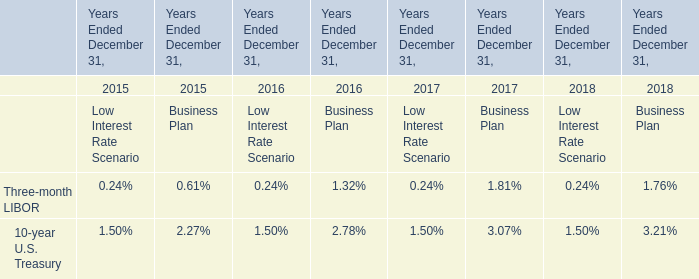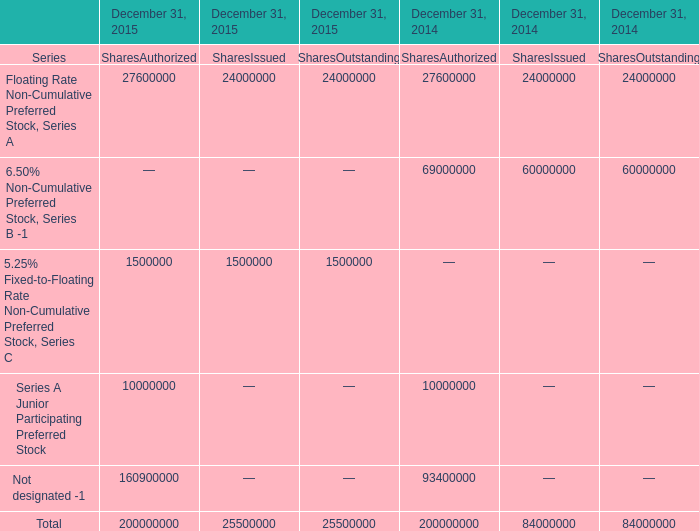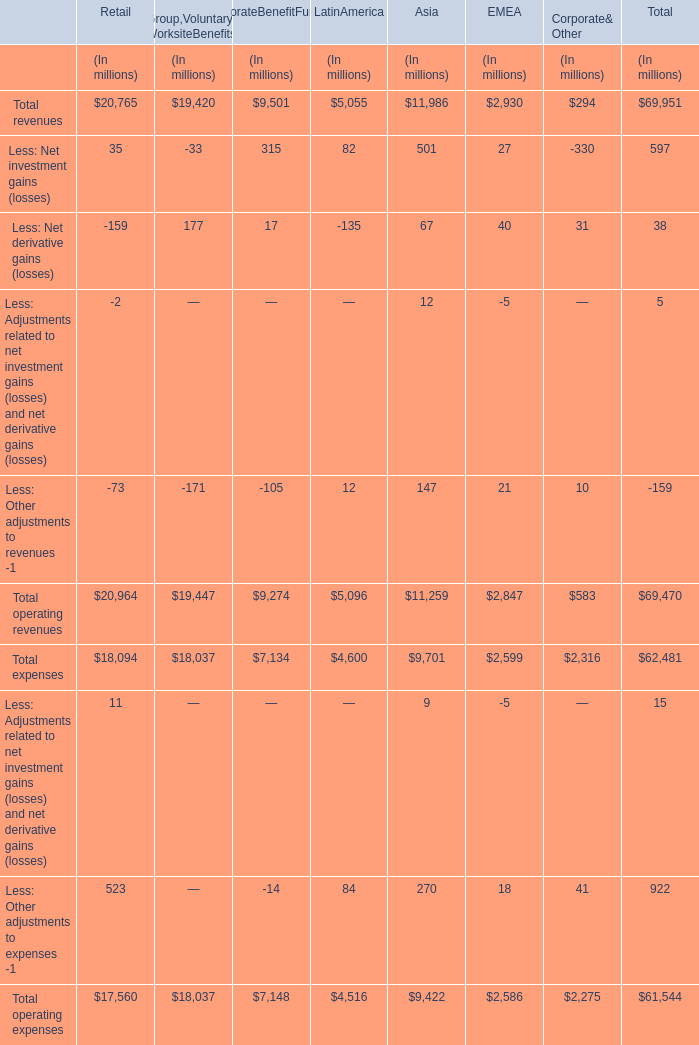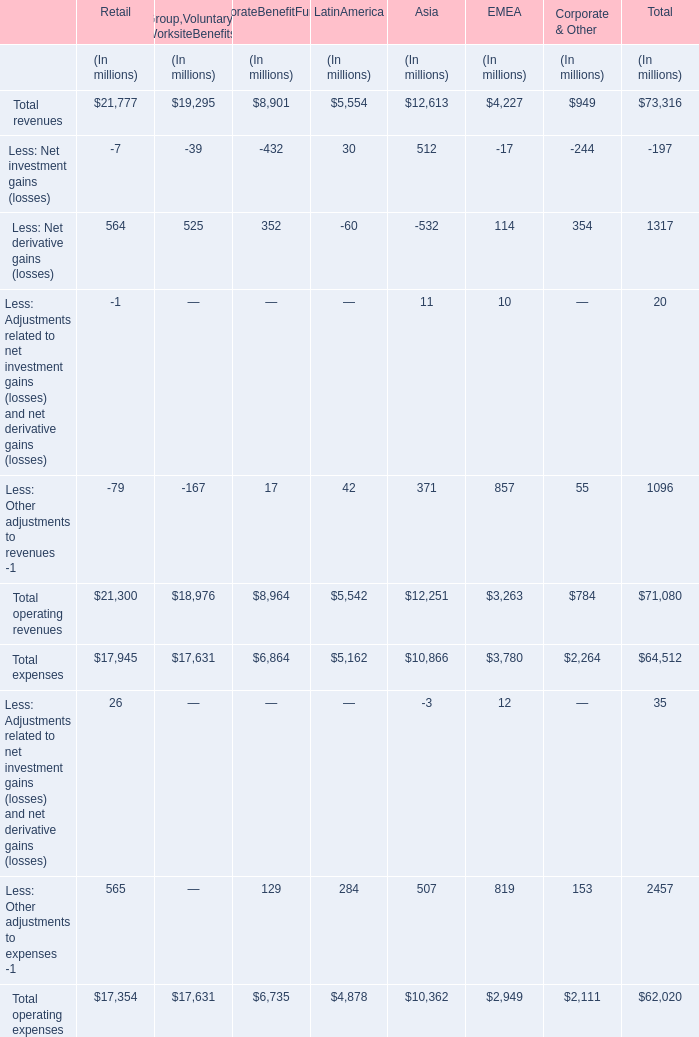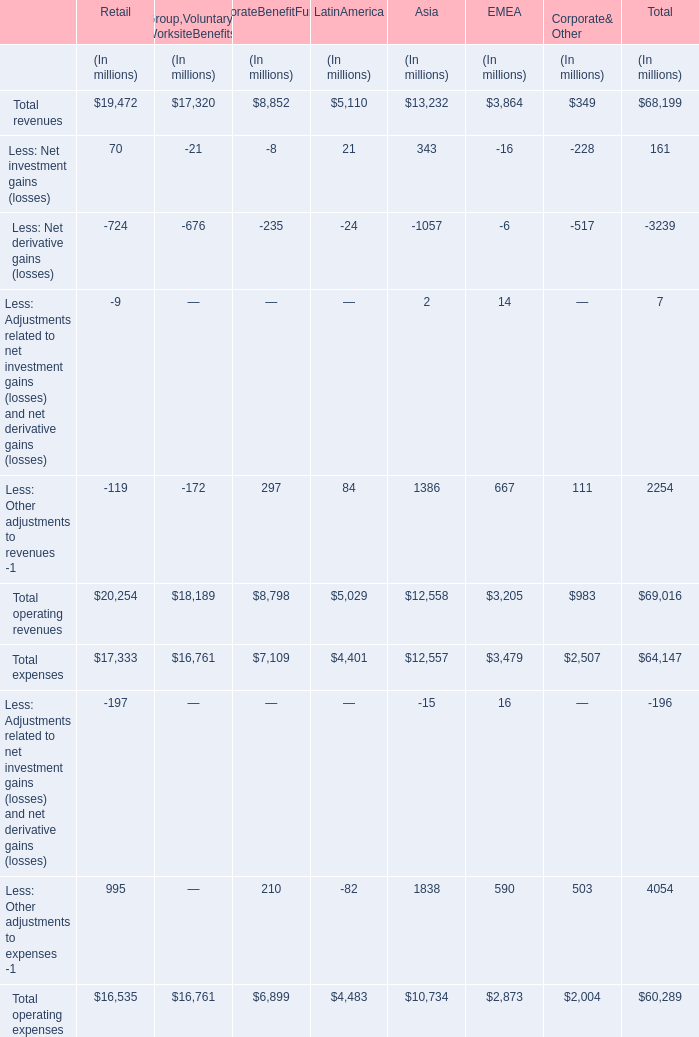In the section with largest amount of Total revenues, what's the sum of Less: Net investment gains (losses) and Less: Net derivative gains (losses) (in million) 
Computations: (70 - 724)
Answer: -654.0. 